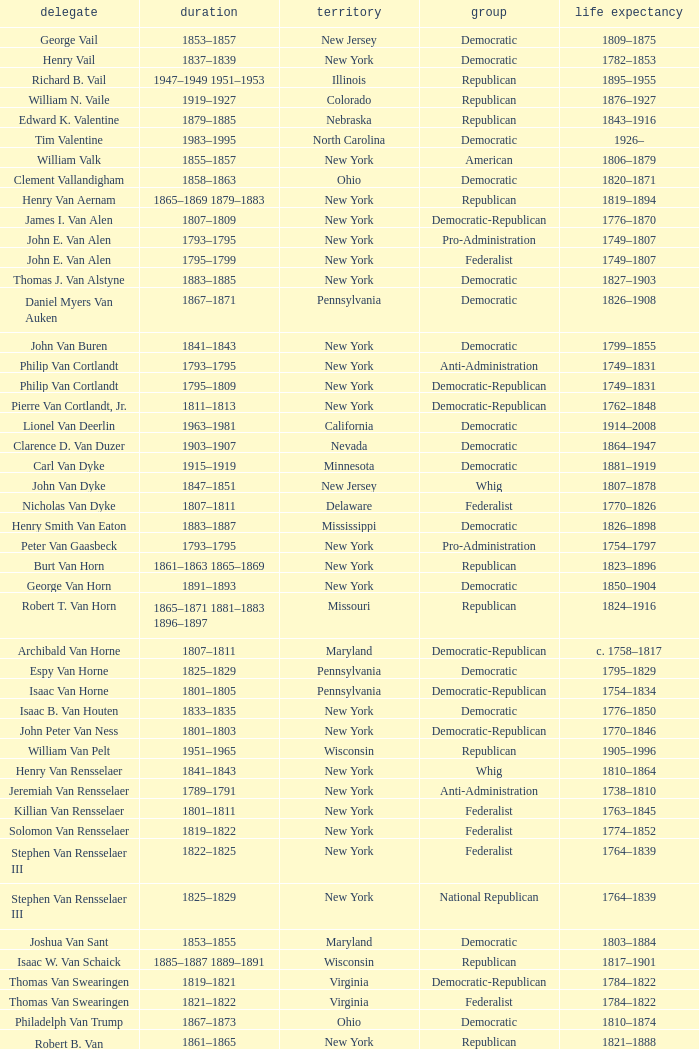What is the lifespan of Joseph Vance, a democratic-republican from Ohio? 1786–1852. 